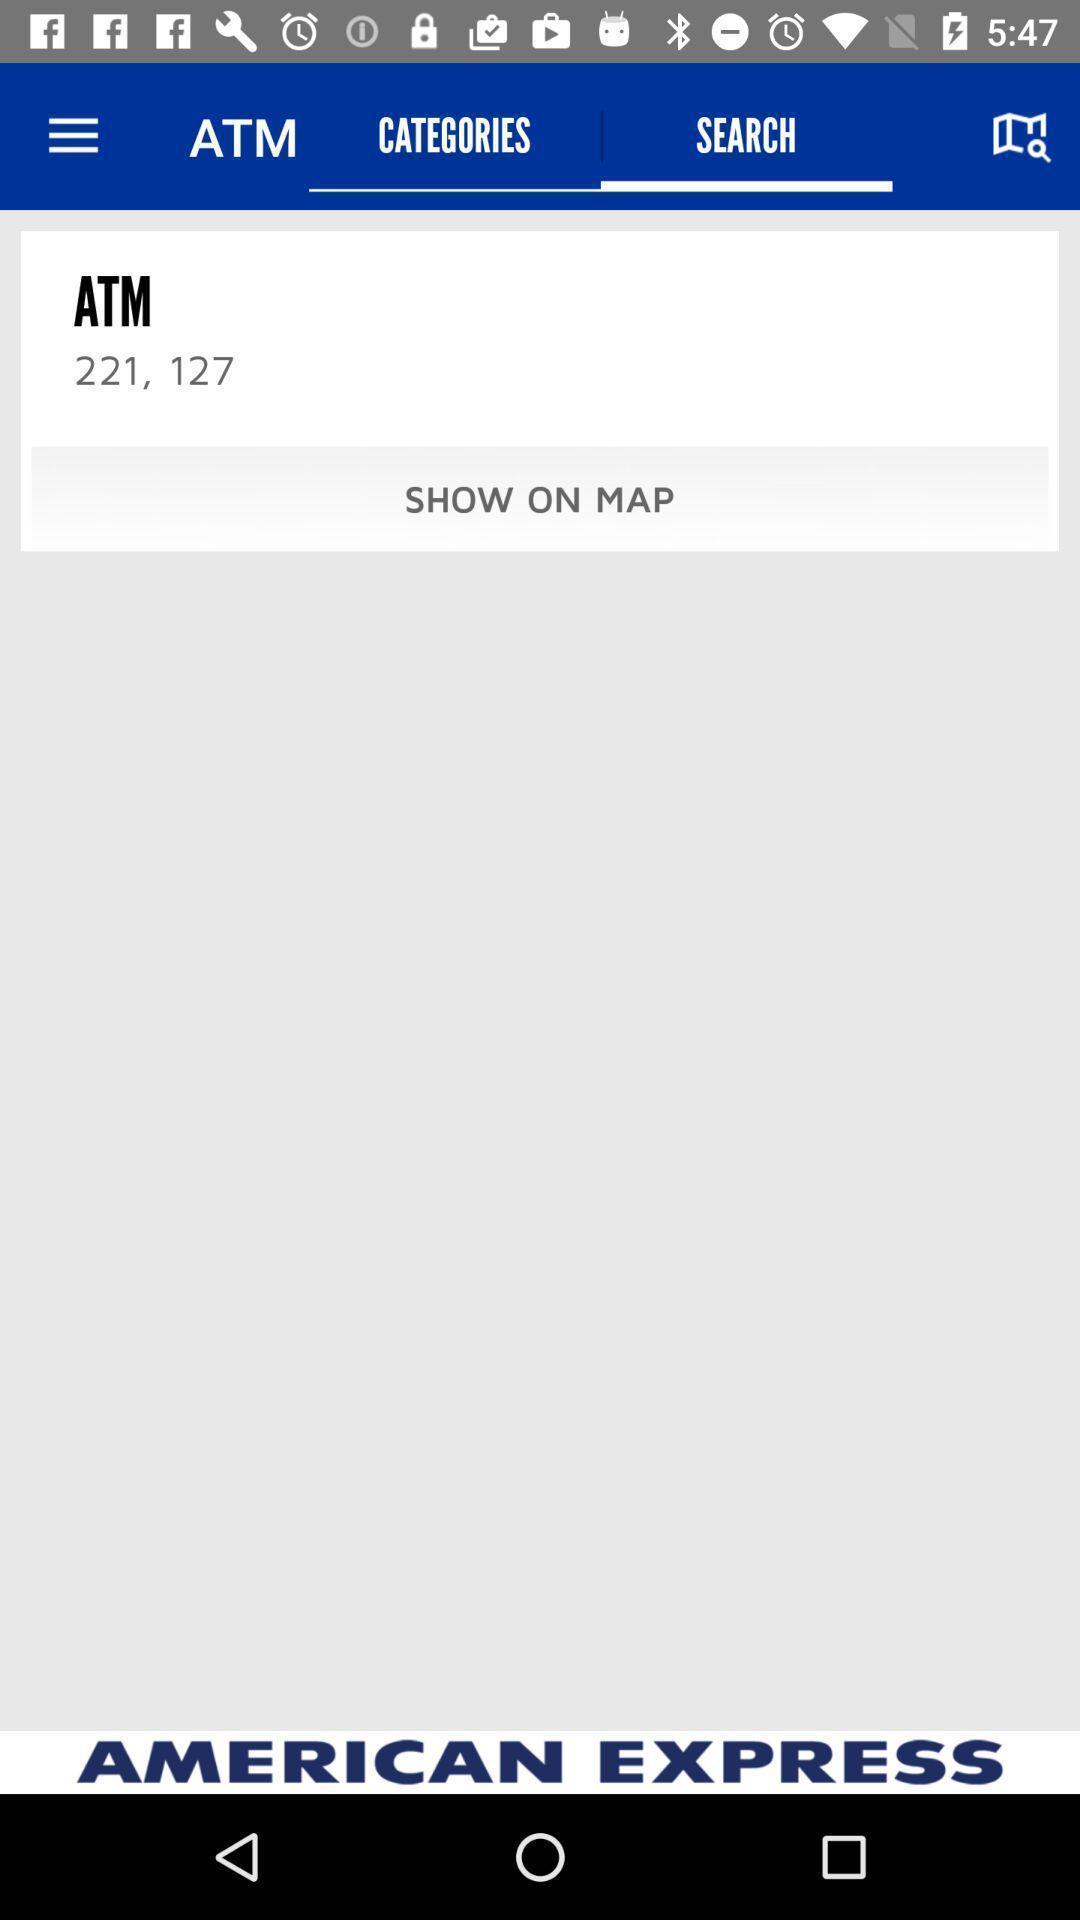Explain what's happening in this screen capture. Page showing information in a sports team related app. 